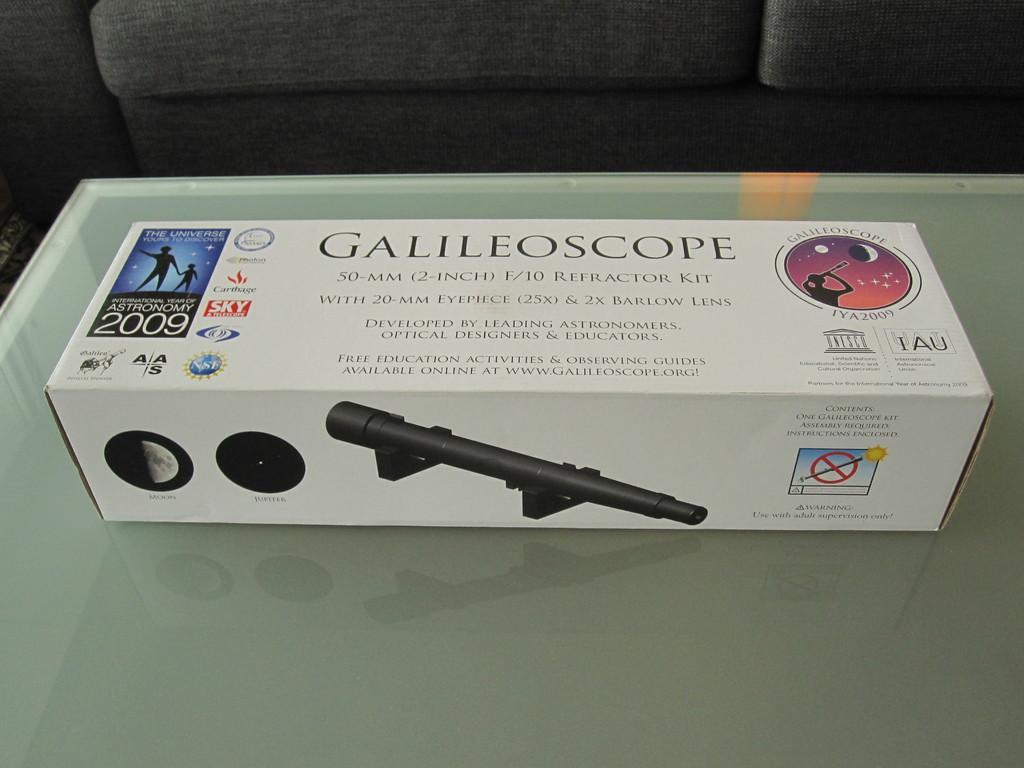Can you describe this image briefly? In this picture I can see a box on which there are few pictures and I see something is written and this box is on the white color surface. In the background I can see the black color things. 